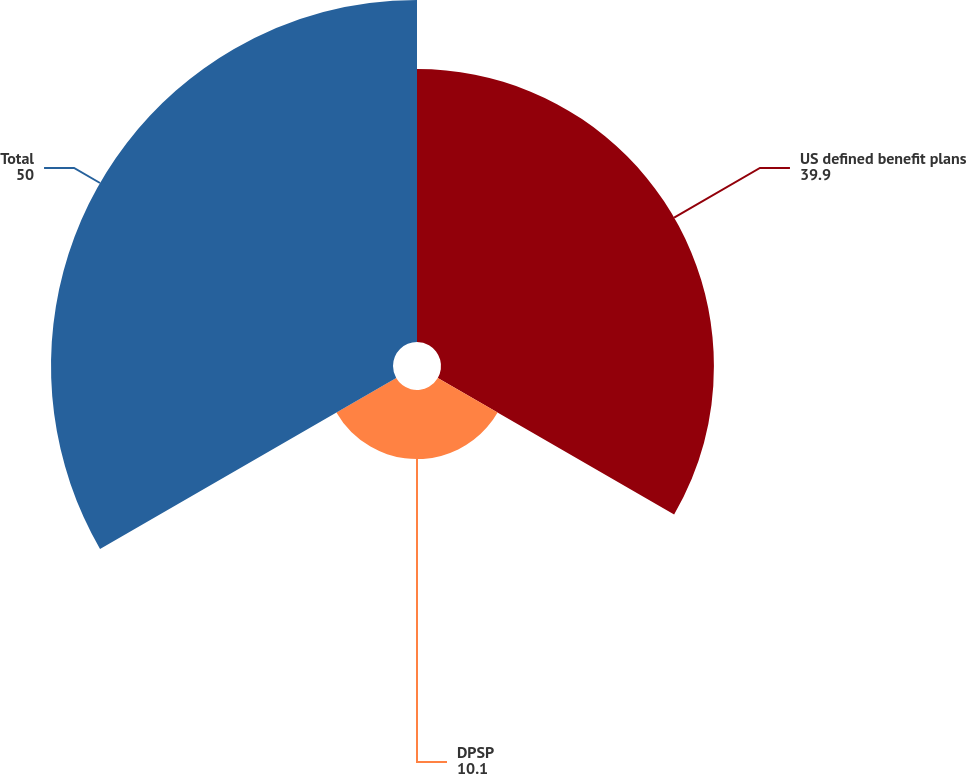Convert chart to OTSL. <chart><loc_0><loc_0><loc_500><loc_500><pie_chart><fcel>US defined benefit plans<fcel>DPSP<fcel>Total<nl><fcel>39.9%<fcel>10.1%<fcel>50.0%<nl></chart> 